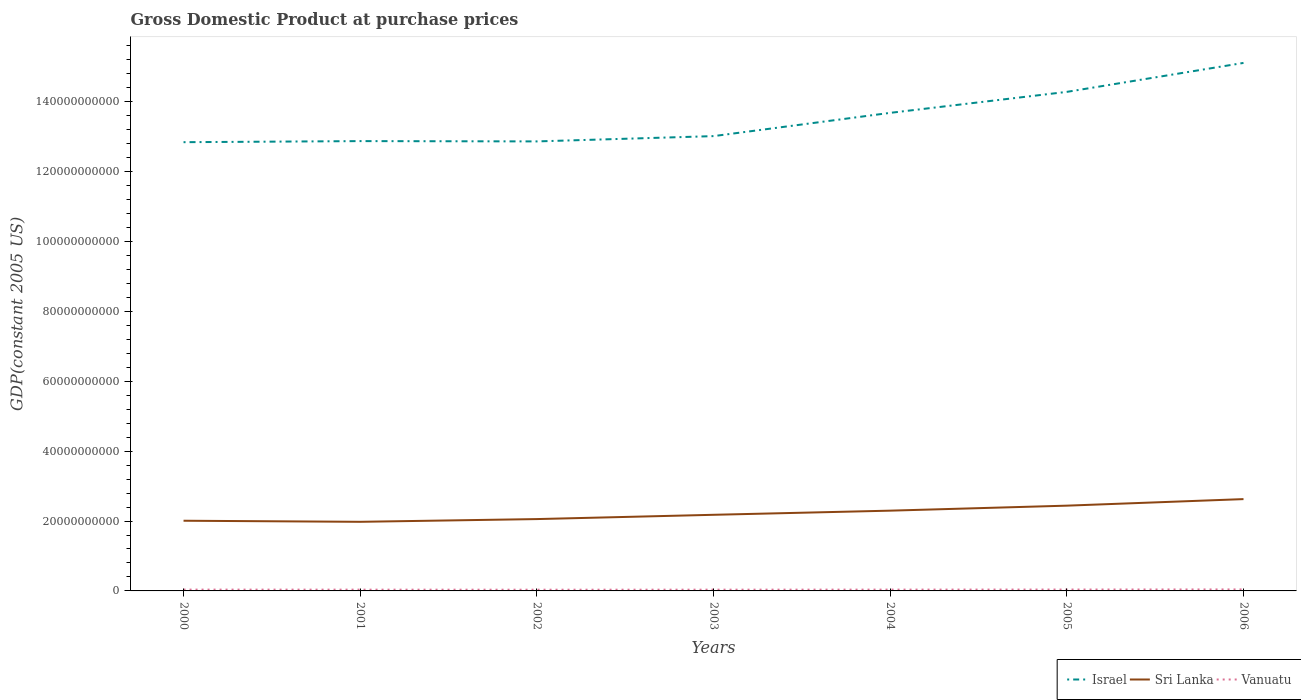Across all years, what is the maximum GDP at purchase prices in Sri Lanka?
Offer a very short reply. 1.98e+1. What is the total GDP at purchase prices in Sri Lanka in the graph?
Your response must be concise. -2.01e+09. What is the difference between the highest and the second highest GDP at purchase prices in Vanuatu?
Your response must be concise. 8.25e+07. Is the GDP at purchase prices in Israel strictly greater than the GDP at purchase prices in Sri Lanka over the years?
Offer a terse response. No. How many legend labels are there?
Give a very brief answer. 3. What is the title of the graph?
Make the answer very short. Gross Domestic Product at purchase prices. Does "Slovenia" appear as one of the legend labels in the graph?
Provide a short and direct response. No. What is the label or title of the X-axis?
Your answer should be compact. Years. What is the label or title of the Y-axis?
Offer a terse response. GDP(constant 2005 US). What is the GDP(constant 2005 US) in Israel in 2000?
Ensure brevity in your answer.  1.28e+11. What is the GDP(constant 2005 US) of Sri Lanka in 2000?
Offer a terse response. 2.01e+1. What is the GDP(constant 2005 US) of Vanuatu in 2000?
Your answer should be very brief. 3.78e+08. What is the GDP(constant 2005 US) in Israel in 2001?
Offer a very short reply. 1.29e+11. What is the GDP(constant 2005 US) of Sri Lanka in 2001?
Make the answer very short. 1.98e+1. What is the GDP(constant 2005 US) of Vanuatu in 2001?
Your answer should be compact. 3.64e+08. What is the GDP(constant 2005 US) of Israel in 2002?
Your response must be concise. 1.29e+11. What is the GDP(constant 2005 US) of Sri Lanka in 2002?
Give a very brief answer. 2.06e+1. What is the GDP(constant 2005 US) in Vanuatu in 2002?
Offer a terse response. 3.46e+08. What is the GDP(constant 2005 US) of Israel in 2003?
Offer a very short reply. 1.30e+11. What is the GDP(constant 2005 US) of Sri Lanka in 2003?
Provide a succinct answer. 2.18e+1. What is the GDP(constant 2005 US) in Vanuatu in 2003?
Provide a succinct answer. 3.61e+08. What is the GDP(constant 2005 US) of Israel in 2004?
Your answer should be compact. 1.37e+11. What is the GDP(constant 2005 US) in Sri Lanka in 2004?
Your answer should be very brief. 2.30e+1. What is the GDP(constant 2005 US) of Vanuatu in 2004?
Offer a very short reply. 3.75e+08. What is the GDP(constant 2005 US) of Israel in 2005?
Offer a terse response. 1.43e+11. What is the GDP(constant 2005 US) of Sri Lanka in 2005?
Your response must be concise. 2.44e+1. What is the GDP(constant 2005 US) of Vanuatu in 2005?
Provide a short and direct response. 3.95e+08. What is the GDP(constant 2005 US) of Israel in 2006?
Offer a terse response. 1.51e+11. What is the GDP(constant 2005 US) in Sri Lanka in 2006?
Provide a succinct answer. 2.63e+1. What is the GDP(constant 2005 US) of Vanuatu in 2006?
Offer a terse response. 4.28e+08. Across all years, what is the maximum GDP(constant 2005 US) of Israel?
Offer a very short reply. 1.51e+11. Across all years, what is the maximum GDP(constant 2005 US) in Sri Lanka?
Your response must be concise. 2.63e+1. Across all years, what is the maximum GDP(constant 2005 US) in Vanuatu?
Offer a terse response. 4.28e+08. Across all years, what is the minimum GDP(constant 2005 US) in Israel?
Make the answer very short. 1.28e+11. Across all years, what is the minimum GDP(constant 2005 US) of Sri Lanka?
Give a very brief answer. 1.98e+1. Across all years, what is the minimum GDP(constant 2005 US) in Vanuatu?
Provide a succinct answer. 3.46e+08. What is the total GDP(constant 2005 US) in Israel in the graph?
Ensure brevity in your answer.  9.47e+11. What is the total GDP(constant 2005 US) in Sri Lanka in the graph?
Your response must be concise. 1.56e+11. What is the total GDP(constant 2005 US) of Vanuatu in the graph?
Your answer should be compact. 2.65e+09. What is the difference between the GDP(constant 2005 US) of Israel in 2000 and that in 2001?
Make the answer very short. -3.10e+08. What is the difference between the GDP(constant 2005 US) in Sri Lanka in 2000 and that in 2001?
Your response must be concise. 3.10e+08. What is the difference between the GDP(constant 2005 US) of Vanuatu in 2000 and that in 2001?
Offer a very short reply. 1.32e+07. What is the difference between the GDP(constant 2005 US) of Israel in 2000 and that in 2002?
Offer a very short reply. -2.22e+08. What is the difference between the GDP(constant 2005 US) in Sri Lanka in 2000 and that in 2002?
Offer a terse response. -4.74e+08. What is the difference between the GDP(constant 2005 US) in Vanuatu in 2000 and that in 2002?
Offer a very short reply. 3.18e+07. What is the difference between the GDP(constant 2005 US) of Israel in 2000 and that in 2003?
Offer a very short reply. -1.74e+09. What is the difference between the GDP(constant 2005 US) in Sri Lanka in 2000 and that in 2003?
Ensure brevity in your answer.  -1.70e+09. What is the difference between the GDP(constant 2005 US) in Vanuatu in 2000 and that in 2003?
Keep it short and to the point. 1.70e+07. What is the difference between the GDP(constant 2005 US) of Israel in 2000 and that in 2004?
Give a very brief answer. -8.39e+09. What is the difference between the GDP(constant 2005 US) of Sri Lanka in 2000 and that in 2004?
Your response must be concise. -2.88e+09. What is the difference between the GDP(constant 2005 US) of Vanuatu in 2000 and that in 2004?
Offer a terse response. 2.58e+06. What is the difference between the GDP(constant 2005 US) in Israel in 2000 and that in 2005?
Your answer should be very brief. -1.44e+1. What is the difference between the GDP(constant 2005 US) of Sri Lanka in 2000 and that in 2005?
Offer a terse response. -4.32e+09. What is the difference between the GDP(constant 2005 US) in Vanuatu in 2000 and that in 2005?
Your answer should be compact. -1.73e+07. What is the difference between the GDP(constant 2005 US) of Israel in 2000 and that in 2006?
Provide a succinct answer. -2.27e+1. What is the difference between the GDP(constant 2005 US) in Sri Lanka in 2000 and that in 2006?
Keep it short and to the point. -6.19e+09. What is the difference between the GDP(constant 2005 US) in Vanuatu in 2000 and that in 2006?
Provide a succinct answer. -5.07e+07. What is the difference between the GDP(constant 2005 US) in Israel in 2001 and that in 2002?
Your response must be concise. 8.79e+07. What is the difference between the GDP(constant 2005 US) of Sri Lanka in 2001 and that in 2002?
Provide a succinct answer. -7.84e+08. What is the difference between the GDP(constant 2005 US) in Vanuatu in 2001 and that in 2002?
Make the answer very short. 1.86e+07. What is the difference between the GDP(constant 2005 US) in Israel in 2001 and that in 2003?
Give a very brief answer. -1.43e+09. What is the difference between the GDP(constant 2005 US) of Sri Lanka in 2001 and that in 2003?
Your response must be concise. -2.01e+09. What is the difference between the GDP(constant 2005 US) of Vanuatu in 2001 and that in 2003?
Keep it short and to the point. 3.78e+06. What is the difference between the GDP(constant 2005 US) of Israel in 2001 and that in 2004?
Give a very brief answer. -8.08e+09. What is the difference between the GDP(constant 2005 US) of Sri Lanka in 2001 and that in 2004?
Keep it short and to the point. -3.19e+09. What is the difference between the GDP(constant 2005 US) in Vanuatu in 2001 and that in 2004?
Provide a succinct answer. -1.06e+07. What is the difference between the GDP(constant 2005 US) of Israel in 2001 and that in 2005?
Your answer should be very brief. -1.41e+1. What is the difference between the GDP(constant 2005 US) of Sri Lanka in 2001 and that in 2005?
Your response must be concise. -4.63e+09. What is the difference between the GDP(constant 2005 US) of Vanuatu in 2001 and that in 2005?
Your answer should be compact. -3.05e+07. What is the difference between the GDP(constant 2005 US) in Israel in 2001 and that in 2006?
Offer a very short reply. -2.24e+1. What is the difference between the GDP(constant 2005 US) of Sri Lanka in 2001 and that in 2006?
Offer a very short reply. -6.50e+09. What is the difference between the GDP(constant 2005 US) of Vanuatu in 2001 and that in 2006?
Provide a succinct answer. -6.39e+07. What is the difference between the GDP(constant 2005 US) in Israel in 2002 and that in 2003?
Offer a terse response. -1.51e+09. What is the difference between the GDP(constant 2005 US) of Sri Lanka in 2002 and that in 2003?
Keep it short and to the point. -1.22e+09. What is the difference between the GDP(constant 2005 US) in Vanuatu in 2002 and that in 2003?
Make the answer very short. -1.48e+07. What is the difference between the GDP(constant 2005 US) in Israel in 2002 and that in 2004?
Offer a terse response. -8.17e+09. What is the difference between the GDP(constant 2005 US) in Sri Lanka in 2002 and that in 2004?
Your answer should be compact. -2.41e+09. What is the difference between the GDP(constant 2005 US) of Vanuatu in 2002 and that in 2004?
Ensure brevity in your answer.  -2.92e+07. What is the difference between the GDP(constant 2005 US) in Israel in 2002 and that in 2005?
Ensure brevity in your answer.  -1.42e+1. What is the difference between the GDP(constant 2005 US) in Sri Lanka in 2002 and that in 2005?
Offer a very short reply. -3.84e+09. What is the difference between the GDP(constant 2005 US) in Vanuatu in 2002 and that in 2005?
Give a very brief answer. -4.91e+07. What is the difference between the GDP(constant 2005 US) of Israel in 2002 and that in 2006?
Provide a succinct answer. -2.25e+1. What is the difference between the GDP(constant 2005 US) of Sri Lanka in 2002 and that in 2006?
Your answer should be very brief. -5.71e+09. What is the difference between the GDP(constant 2005 US) in Vanuatu in 2002 and that in 2006?
Make the answer very short. -8.25e+07. What is the difference between the GDP(constant 2005 US) in Israel in 2003 and that in 2004?
Your response must be concise. -6.66e+09. What is the difference between the GDP(constant 2005 US) of Sri Lanka in 2003 and that in 2004?
Offer a terse response. -1.19e+09. What is the difference between the GDP(constant 2005 US) of Vanuatu in 2003 and that in 2004?
Keep it short and to the point. -1.44e+07. What is the difference between the GDP(constant 2005 US) of Israel in 2003 and that in 2005?
Give a very brief answer. -1.27e+1. What is the difference between the GDP(constant 2005 US) of Sri Lanka in 2003 and that in 2005?
Offer a terse response. -2.62e+09. What is the difference between the GDP(constant 2005 US) in Vanuatu in 2003 and that in 2005?
Your answer should be very brief. -3.43e+07. What is the difference between the GDP(constant 2005 US) of Israel in 2003 and that in 2006?
Give a very brief answer. -2.10e+1. What is the difference between the GDP(constant 2005 US) in Sri Lanka in 2003 and that in 2006?
Provide a short and direct response. -4.49e+09. What is the difference between the GDP(constant 2005 US) of Vanuatu in 2003 and that in 2006?
Your answer should be compact. -6.77e+07. What is the difference between the GDP(constant 2005 US) in Israel in 2004 and that in 2005?
Offer a terse response. -6.01e+09. What is the difference between the GDP(constant 2005 US) in Sri Lanka in 2004 and that in 2005?
Provide a short and direct response. -1.43e+09. What is the difference between the GDP(constant 2005 US) in Vanuatu in 2004 and that in 2005?
Make the answer very short. -1.99e+07. What is the difference between the GDP(constant 2005 US) of Israel in 2004 and that in 2006?
Provide a succinct answer. -1.43e+1. What is the difference between the GDP(constant 2005 US) in Sri Lanka in 2004 and that in 2006?
Provide a short and direct response. -3.31e+09. What is the difference between the GDP(constant 2005 US) in Vanuatu in 2004 and that in 2006?
Provide a short and direct response. -5.33e+07. What is the difference between the GDP(constant 2005 US) in Israel in 2005 and that in 2006?
Your answer should be very brief. -8.29e+09. What is the difference between the GDP(constant 2005 US) in Sri Lanka in 2005 and that in 2006?
Your answer should be very brief. -1.87e+09. What is the difference between the GDP(constant 2005 US) of Vanuatu in 2005 and that in 2006?
Your answer should be very brief. -3.34e+07. What is the difference between the GDP(constant 2005 US) of Israel in 2000 and the GDP(constant 2005 US) of Sri Lanka in 2001?
Your answer should be very brief. 1.09e+11. What is the difference between the GDP(constant 2005 US) of Israel in 2000 and the GDP(constant 2005 US) of Vanuatu in 2001?
Your answer should be very brief. 1.28e+11. What is the difference between the GDP(constant 2005 US) in Sri Lanka in 2000 and the GDP(constant 2005 US) in Vanuatu in 2001?
Your answer should be very brief. 1.97e+1. What is the difference between the GDP(constant 2005 US) in Israel in 2000 and the GDP(constant 2005 US) in Sri Lanka in 2002?
Your answer should be compact. 1.08e+11. What is the difference between the GDP(constant 2005 US) in Israel in 2000 and the GDP(constant 2005 US) in Vanuatu in 2002?
Provide a succinct answer. 1.28e+11. What is the difference between the GDP(constant 2005 US) of Sri Lanka in 2000 and the GDP(constant 2005 US) of Vanuatu in 2002?
Provide a short and direct response. 1.97e+1. What is the difference between the GDP(constant 2005 US) of Israel in 2000 and the GDP(constant 2005 US) of Sri Lanka in 2003?
Give a very brief answer. 1.07e+11. What is the difference between the GDP(constant 2005 US) in Israel in 2000 and the GDP(constant 2005 US) in Vanuatu in 2003?
Your answer should be compact. 1.28e+11. What is the difference between the GDP(constant 2005 US) of Sri Lanka in 2000 and the GDP(constant 2005 US) of Vanuatu in 2003?
Provide a short and direct response. 1.97e+1. What is the difference between the GDP(constant 2005 US) in Israel in 2000 and the GDP(constant 2005 US) in Sri Lanka in 2004?
Ensure brevity in your answer.  1.05e+11. What is the difference between the GDP(constant 2005 US) in Israel in 2000 and the GDP(constant 2005 US) in Vanuatu in 2004?
Your answer should be very brief. 1.28e+11. What is the difference between the GDP(constant 2005 US) in Sri Lanka in 2000 and the GDP(constant 2005 US) in Vanuatu in 2004?
Your answer should be very brief. 1.97e+1. What is the difference between the GDP(constant 2005 US) in Israel in 2000 and the GDP(constant 2005 US) in Sri Lanka in 2005?
Keep it short and to the point. 1.04e+11. What is the difference between the GDP(constant 2005 US) in Israel in 2000 and the GDP(constant 2005 US) in Vanuatu in 2005?
Your answer should be compact. 1.28e+11. What is the difference between the GDP(constant 2005 US) in Sri Lanka in 2000 and the GDP(constant 2005 US) in Vanuatu in 2005?
Make the answer very short. 1.97e+1. What is the difference between the GDP(constant 2005 US) in Israel in 2000 and the GDP(constant 2005 US) in Sri Lanka in 2006?
Your answer should be compact. 1.02e+11. What is the difference between the GDP(constant 2005 US) in Israel in 2000 and the GDP(constant 2005 US) in Vanuatu in 2006?
Provide a short and direct response. 1.28e+11. What is the difference between the GDP(constant 2005 US) in Sri Lanka in 2000 and the GDP(constant 2005 US) in Vanuatu in 2006?
Give a very brief answer. 1.97e+1. What is the difference between the GDP(constant 2005 US) in Israel in 2001 and the GDP(constant 2005 US) in Sri Lanka in 2002?
Ensure brevity in your answer.  1.08e+11. What is the difference between the GDP(constant 2005 US) of Israel in 2001 and the GDP(constant 2005 US) of Vanuatu in 2002?
Keep it short and to the point. 1.28e+11. What is the difference between the GDP(constant 2005 US) in Sri Lanka in 2001 and the GDP(constant 2005 US) in Vanuatu in 2002?
Offer a very short reply. 1.94e+1. What is the difference between the GDP(constant 2005 US) of Israel in 2001 and the GDP(constant 2005 US) of Sri Lanka in 2003?
Provide a succinct answer. 1.07e+11. What is the difference between the GDP(constant 2005 US) in Israel in 2001 and the GDP(constant 2005 US) in Vanuatu in 2003?
Your answer should be compact. 1.28e+11. What is the difference between the GDP(constant 2005 US) in Sri Lanka in 2001 and the GDP(constant 2005 US) in Vanuatu in 2003?
Offer a terse response. 1.94e+1. What is the difference between the GDP(constant 2005 US) of Israel in 2001 and the GDP(constant 2005 US) of Sri Lanka in 2004?
Provide a short and direct response. 1.06e+11. What is the difference between the GDP(constant 2005 US) of Israel in 2001 and the GDP(constant 2005 US) of Vanuatu in 2004?
Keep it short and to the point. 1.28e+11. What is the difference between the GDP(constant 2005 US) in Sri Lanka in 2001 and the GDP(constant 2005 US) in Vanuatu in 2004?
Your answer should be very brief. 1.94e+1. What is the difference between the GDP(constant 2005 US) of Israel in 2001 and the GDP(constant 2005 US) of Sri Lanka in 2005?
Your answer should be very brief. 1.04e+11. What is the difference between the GDP(constant 2005 US) of Israel in 2001 and the GDP(constant 2005 US) of Vanuatu in 2005?
Ensure brevity in your answer.  1.28e+11. What is the difference between the GDP(constant 2005 US) in Sri Lanka in 2001 and the GDP(constant 2005 US) in Vanuatu in 2005?
Give a very brief answer. 1.94e+1. What is the difference between the GDP(constant 2005 US) of Israel in 2001 and the GDP(constant 2005 US) of Sri Lanka in 2006?
Make the answer very short. 1.02e+11. What is the difference between the GDP(constant 2005 US) in Israel in 2001 and the GDP(constant 2005 US) in Vanuatu in 2006?
Provide a succinct answer. 1.28e+11. What is the difference between the GDP(constant 2005 US) in Sri Lanka in 2001 and the GDP(constant 2005 US) in Vanuatu in 2006?
Provide a short and direct response. 1.94e+1. What is the difference between the GDP(constant 2005 US) in Israel in 2002 and the GDP(constant 2005 US) in Sri Lanka in 2003?
Offer a terse response. 1.07e+11. What is the difference between the GDP(constant 2005 US) in Israel in 2002 and the GDP(constant 2005 US) in Vanuatu in 2003?
Provide a succinct answer. 1.28e+11. What is the difference between the GDP(constant 2005 US) of Sri Lanka in 2002 and the GDP(constant 2005 US) of Vanuatu in 2003?
Offer a terse response. 2.02e+1. What is the difference between the GDP(constant 2005 US) of Israel in 2002 and the GDP(constant 2005 US) of Sri Lanka in 2004?
Provide a short and direct response. 1.06e+11. What is the difference between the GDP(constant 2005 US) in Israel in 2002 and the GDP(constant 2005 US) in Vanuatu in 2004?
Provide a succinct answer. 1.28e+11. What is the difference between the GDP(constant 2005 US) of Sri Lanka in 2002 and the GDP(constant 2005 US) of Vanuatu in 2004?
Your answer should be very brief. 2.02e+1. What is the difference between the GDP(constant 2005 US) in Israel in 2002 and the GDP(constant 2005 US) in Sri Lanka in 2005?
Ensure brevity in your answer.  1.04e+11. What is the difference between the GDP(constant 2005 US) in Israel in 2002 and the GDP(constant 2005 US) in Vanuatu in 2005?
Provide a short and direct response. 1.28e+11. What is the difference between the GDP(constant 2005 US) of Sri Lanka in 2002 and the GDP(constant 2005 US) of Vanuatu in 2005?
Your answer should be very brief. 2.02e+1. What is the difference between the GDP(constant 2005 US) in Israel in 2002 and the GDP(constant 2005 US) in Sri Lanka in 2006?
Make the answer very short. 1.02e+11. What is the difference between the GDP(constant 2005 US) in Israel in 2002 and the GDP(constant 2005 US) in Vanuatu in 2006?
Provide a short and direct response. 1.28e+11. What is the difference between the GDP(constant 2005 US) in Sri Lanka in 2002 and the GDP(constant 2005 US) in Vanuatu in 2006?
Provide a succinct answer. 2.01e+1. What is the difference between the GDP(constant 2005 US) in Israel in 2003 and the GDP(constant 2005 US) in Sri Lanka in 2004?
Offer a terse response. 1.07e+11. What is the difference between the GDP(constant 2005 US) in Israel in 2003 and the GDP(constant 2005 US) in Vanuatu in 2004?
Provide a short and direct response. 1.30e+11. What is the difference between the GDP(constant 2005 US) in Sri Lanka in 2003 and the GDP(constant 2005 US) in Vanuatu in 2004?
Your answer should be compact. 2.14e+1. What is the difference between the GDP(constant 2005 US) of Israel in 2003 and the GDP(constant 2005 US) of Sri Lanka in 2005?
Offer a very short reply. 1.06e+11. What is the difference between the GDP(constant 2005 US) in Israel in 2003 and the GDP(constant 2005 US) in Vanuatu in 2005?
Give a very brief answer. 1.30e+11. What is the difference between the GDP(constant 2005 US) of Sri Lanka in 2003 and the GDP(constant 2005 US) of Vanuatu in 2005?
Provide a short and direct response. 2.14e+1. What is the difference between the GDP(constant 2005 US) of Israel in 2003 and the GDP(constant 2005 US) of Sri Lanka in 2006?
Your response must be concise. 1.04e+11. What is the difference between the GDP(constant 2005 US) of Israel in 2003 and the GDP(constant 2005 US) of Vanuatu in 2006?
Provide a succinct answer. 1.30e+11. What is the difference between the GDP(constant 2005 US) in Sri Lanka in 2003 and the GDP(constant 2005 US) in Vanuatu in 2006?
Provide a succinct answer. 2.14e+1. What is the difference between the GDP(constant 2005 US) in Israel in 2004 and the GDP(constant 2005 US) in Sri Lanka in 2005?
Your answer should be compact. 1.12e+11. What is the difference between the GDP(constant 2005 US) of Israel in 2004 and the GDP(constant 2005 US) of Vanuatu in 2005?
Your answer should be compact. 1.36e+11. What is the difference between the GDP(constant 2005 US) in Sri Lanka in 2004 and the GDP(constant 2005 US) in Vanuatu in 2005?
Make the answer very short. 2.26e+1. What is the difference between the GDP(constant 2005 US) of Israel in 2004 and the GDP(constant 2005 US) of Sri Lanka in 2006?
Your answer should be compact. 1.11e+11. What is the difference between the GDP(constant 2005 US) in Israel in 2004 and the GDP(constant 2005 US) in Vanuatu in 2006?
Give a very brief answer. 1.36e+11. What is the difference between the GDP(constant 2005 US) in Sri Lanka in 2004 and the GDP(constant 2005 US) in Vanuatu in 2006?
Ensure brevity in your answer.  2.25e+1. What is the difference between the GDP(constant 2005 US) in Israel in 2005 and the GDP(constant 2005 US) in Sri Lanka in 2006?
Provide a short and direct response. 1.17e+11. What is the difference between the GDP(constant 2005 US) of Israel in 2005 and the GDP(constant 2005 US) of Vanuatu in 2006?
Give a very brief answer. 1.42e+11. What is the difference between the GDP(constant 2005 US) in Sri Lanka in 2005 and the GDP(constant 2005 US) in Vanuatu in 2006?
Ensure brevity in your answer.  2.40e+1. What is the average GDP(constant 2005 US) of Israel per year?
Keep it short and to the point. 1.35e+11. What is the average GDP(constant 2005 US) of Sri Lanka per year?
Give a very brief answer. 2.23e+1. What is the average GDP(constant 2005 US) in Vanuatu per year?
Keep it short and to the point. 3.78e+08. In the year 2000, what is the difference between the GDP(constant 2005 US) in Israel and GDP(constant 2005 US) in Sri Lanka?
Make the answer very short. 1.08e+11. In the year 2000, what is the difference between the GDP(constant 2005 US) in Israel and GDP(constant 2005 US) in Vanuatu?
Offer a very short reply. 1.28e+11. In the year 2000, what is the difference between the GDP(constant 2005 US) in Sri Lanka and GDP(constant 2005 US) in Vanuatu?
Provide a short and direct response. 1.97e+1. In the year 2001, what is the difference between the GDP(constant 2005 US) in Israel and GDP(constant 2005 US) in Sri Lanka?
Your answer should be very brief. 1.09e+11. In the year 2001, what is the difference between the GDP(constant 2005 US) of Israel and GDP(constant 2005 US) of Vanuatu?
Ensure brevity in your answer.  1.28e+11. In the year 2001, what is the difference between the GDP(constant 2005 US) in Sri Lanka and GDP(constant 2005 US) in Vanuatu?
Offer a very short reply. 1.94e+1. In the year 2002, what is the difference between the GDP(constant 2005 US) of Israel and GDP(constant 2005 US) of Sri Lanka?
Your response must be concise. 1.08e+11. In the year 2002, what is the difference between the GDP(constant 2005 US) of Israel and GDP(constant 2005 US) of Vanuatu?
Provide a succinct answer. 1.28e+11. In the year 2002, what is the difference between the GDP(constant 2005 US) in Sri Lanka and GDP(constant 2005 US) in Vanuatu?
Ensure brevity in your answer.  2.02e+1. In the year 2003, what is the difference between the GDP(constant 2005 US) of Israel and GDP(constant 2005 US) of Sri Lanka?
Ensure brevity in your answer.  1.08e+11. In the year 2003, what is the difference between the GDP(constant 2005 US) in Israel and GDP(constant 2005 US) in Vanuatu?
Make the answer very short. 1.30e+11. In the year 2003, what is the difference between the GDP(constant 2005 US) in Sri Lanka and GDP(constant 2005 US) in Vanuatu?
Ensure brevity in your answer.  2.14e+1. In the year 2004, what is the difference between the GDP(constant 2005 US) of Israel and GDP(constant 2005 US) of Sri Lanka?
Provide a succinct answer. 1.14e+11. In the year 2004, what is the difference between the GDP(constant 2005 US) of Israel and GDP(constant 2005 US) of Vanuatu?
Give a very brief answer. 1.36e+11. In the year 2004, what is the difference between the GDP(constant 2005 US) in Sri Lanka and GDP(constant 2005 US) in Vanuatu?
Make the answer very short. 2.26e+1. In the year 2005, what is the difference between the GDP(constant 2005 US) of Israel and GDP(constant 2005 US) of Sri Lanka?
Offer a terse response. 1.18e+11. In the year 2005, what is the difference between the GDP(constant 2005 US) of Israel and GDP(constant 2005 US) of Vanuatu?
Ensure brevity in your answer.  1.42e+11. In the year 2005, what is the difference between the GDP(constant 2005 US) of Sri Lanka and GDP(constant 2005 US) of Vanuatu?
Offer a very short reply. 2.40e+1. In the year 2006, what is the difference between the GDP(constant 2005 US) of Israel and GDP(constant 2005 US) of Sri Lanka?
Provide a short and direct response. 1.25e+11. In the year 2006, what is the difference between the GDP(constant 2005 US) in Israel and GDP(constant 2005 US) in Vanuatu?
Ensure brevity in your answer.  1.51e+11. In the year 2006, what is the difference between the GDP(constant 2005 US) in Sri Lanka and GDP(constant 2005 US) in Vanuatu?
Give a very brief answer. 2.58e+1. What is the ratio of the GDP(constant 2005 US) in Sri Lanka in 2000 to that in 2001?
Your response must be concise. 1.02. What is the ratio of the GDP(constant 2005 US) in Vanuatu in 2000 to that in 2001?
Provide a short and direct response. 1.04. What is the ratio of the GDP(constant 2005 US) in Israel in 2000 to that in 2002?
Make the answer very short. 1. What is the ratio of the GDP(constant 2005 US) in Sri Lanka in 2000 to that in 2002?
Make the answer very short. 0.98. What is the ratio of the GDP(constant 2005 US) of Vanuatu in 2000 to that in 2002?
Give a very brief answer. 1.09. What is the ratio of the GDP(constant 2005 US) of Israel in 2000 to that in 2003?
Your answer should be very brief. 0.99. What is the ratio of the GDP(constant 2005 US) of Sri Lanka in 2000 to that in 2003?
Your answer should be compact. 0.92. What is the ratio of the GDP(constant 2005 US) of Vanuatu in 2000 to that in 2003?
Make the answer very short. 1.05. What is the ratio of the GDP(constant 2005 US) of Israel in 2000 to that in 2004?
Offer a very short reply. 0.94. What is the ratio of the GDP(constant 2005 US) of Sri Lanka in 2000 to that in 2004?
Offer a very short reply. 0.87. What is the ratio of the GDP(constant 2005 US) in Vanuatu in 2000 to that in 2004?
Make the answer very short. 1.01. What is the ratio of the GDP(constant 2005 US) in Israel in 2000 to that in 2005?
Make the answer very short. 0.9. What is the ratio of the GDP(constant 2005 US) in Sri Lanka in 2000 to that in 2005?
Provide a succinct answer. 0.82. What is the ratio of the GDP(constant 2005 US) of Vanuatu in 2000 to that in 2005?
Provide a short and direct response. 0.96. What is the ratio of the GDP(constant 2005 US) in Israel in 2000 to that in 2006?
Offer a terse response. 0.85. What is the ratio of the GDP(constant 2005 US) in Sri Lanka in 2000 to that in 2006?
Your response must be concise. 0.76. What is the ratio of the GDP(constant 2005 US) of Vanuatu in 2000 to that in 2006?
Your answer should be compact. 0.88. What is the ratio of the GDP(constant 2005 US) in Israel in 2001 to that in 2002?
Offer a terse response. 1. What is the ratio of the GDP(constant 2005 US) of Sri Lanka in 2001 to that in 2002?
Your answer should be compact. 0.96. What is the ratio of the GDP(constant 2005 US) of Vanuatu in 2001 to that in 2002?
Make the answer very short. 1.05. What is the ratio of the GDP(constant 2005 US) in Sri Lanka in 2001 to that in 2003?
Offer a very short reply. 0.91. What is the ratio of the GDP(constant 2005 US) of Vanuatu in 2001 to that in 2003?
Provide a short and direct response. 1.01. What is the ratio of the GDP(constant 2005 US) of Israel in 2001 to that in 2004?
Offer a very short reply. 0.94. What is the ratio of the GDP(constant 2005 US) in Sri Lanka in 2001 to that in 2004?
Your response must be concise. 0.86. What is the ratio of the GDP(constant 2005 US) in Vanuatu in 2001 to that in 2004?
Keep it short and to the point. 0.97. What is the ratio of the GDP(constant 2005 US) of Israel in 2001 to that in 2005?
Provide a succinct answer. 0.9. What is the ratio of the GDP(constant 2005 US) in Sri Lanka in 2001 to that in 2005?
Offer a terse response. 0.81. What is the ratio of the GDP(constant 2005 US) in Vanuatu in 2001 to that in 2005?
Provide a succinct answer. 0.92. What is the ratio of the GDP(constant 2005 US) of Israel in 2001 to that in 2006?
Make the answer very short. 0.85. What is the ratio of the GDP(constant 2005 US) of Sri Lanka in 2001 to that in 2006?
Keep it short and to the point. 0.75. What is the ratio of the GDP(constant 2005 US) in Vanuatu in 2001 to that in 2006?
Your answer should be very brief. 0.85. What is the ratio of the GDP(constant 2005 US) in Israel in 2002 to that in 2003?
Offer a very short reply. 0.99. What is the ratio of the GDP(constant 2005 US) of Sri Lanka in 2002 to that in 2003?
Your answer should be very brief. 0.94. What is the ratio of the GDP(constant 2005 US) in Vanuatu in 2002 to that in 2003?
Provide a succinct answer. 0.96. What is the ratio of the GDP(constant 2005 US) in Israel in 2002 to that in 2004?
Offer a terse response. 0.94. What is the ratio of the GDP(constant 2005 US) in Sri Lanka in 2002 to that in 2004?
Your response must be concise. 0.9. What is the ratio of the GDP(constant 2005 US) in Vanuatu in 2002 to that in 2004?
Ensure brevity in your answer.  0.92. What is the ratio of the GDP(constant 2005 US) of Israel in 2002 to that in 2005?
Your response must be concise. 0.9. What is the ratio of the GDP(constant 2005 US) in Sri Lanka in 2002 to that in 2005?
Your response must be concise. 0.84. What is the ratio of the GDP(constant 2005 US) in Vanuatu in 2002 to that in 2005?
Offer a very short reply. 0.88. What is the ratio of the GDP(constant 2005 US) of Israel in 2002 to that in 2006?
Your response must be concise. 0.85. What is the ratio of the GDP(constant 2005 US) of Sri Lanka in 2002 to that in 2006?
Provide a short and direct response. 0.78. What is the ratio of the GDP(constant 2005 US) of Vanuatu in 2002 to that in 2006?
Your answer should be compact. 0.81. What is the ratio of the GDP(constant 2005 US) in Israel in 2003 to that in 2004?
Ensure brevity in your answer.  0.95. What is the ratio of the GDP(constant 2005 US) of Sri Lanka in 2003 to that in 2004?
Offer a terse response. 0.95. What is the ratio of the GDP(constant 2005 US) of Vanuatu in 2003 to that in 2004?
Make the answer very short. 0.96. What is the ratio of the GDP(constant 2005 US) in Israel in 2003 to that in 2005?
Give a very brief answer. 0.91. What is the ratio of the GDP(constant 2005 US) in Sri Lanka in 2003 to that in 2005?
Offer a terse response. 0.89. What is the ratio of the GDP(constant 2005 US) of Vanuatu in 2003 to that in 2005?
Give a very brief answer. 0.91. What is the ratio of the GDP(constant 2005 US) of Israel in 2003 to that in 2006?
Ensure brevity in your answer.  0.86. What is the ratio of the GDP(constant 2005 US) in Sri Lanka in 2003 to that in 2006?
Your answer should be very brief. 0.83. What is the ratio of the GDP(constant 2005 US) of Vanuatu in 2003 to that in 2006?
Provide a short and direct response. 0.84. What is the ratio of the GDP(constant 2005 US) of Israel in 2004 to that in 2005?
Offer a terse response. 0.96. What is the ratio of the GDP(constant 2005 US) of Vanuatu in 2004 to that in 2005?
Offer a terse response. 0.95. What is the ratio of the GDP(constant 2005 US) of Israel in 2004 to that in 2006?
Provide a short and direct response. 0.91. What is the ratio of the GDP(constant 2005 US) in Sri Lanka in 2004 to that in 2006?
Provide a succinct answer. 0.87. What is the ratio of the GDP(constant 2005 US) of Vanuatu in 2004 to that in 2006?
Provide a succinct answer. 0.88. What is the ratio of the GDP(constant 2005 US) of Israel in 2005 to that in 2006?
Give a very brief answer. 0.95. What is the ratio of the GDP(constant 2005 US) in Sri Lanka in 2005 to that in 2006?
Make the answer very short. 0.93. What is the ratio of the GDP(constant 2005 US) of Vanuatu in 2005 to that in 2006?
Ensure brevity in your answer.  0.92. What is the difference between the highest and the second highest GDP(constant 2005 US) of Israel?
Your answer should be compact. 8.29e+09. What is the difference between the highest and the second highest GDP(constant 2005 US) in Sri Lanka?
Provide a short and direct response. 1.87e+09. What is the difference between the highest and the second highest GDP(constant 2005 US) in Vanuatu?
Offer a terse response. 3.34e+07. What is the difference between the highest and the lowest GDP(constant 2005 US) of Israel?
Your response must be concise. 2.27e+1. What is the difference between the highest and the lowest GDP(constant 2005 US) of Sri Lanka?
Your answer should be very brief. 6.50e+09. What is the difference between the highest and the lowest GDP(constant 2005 US) in Vanuatu?
Your answer should be compact. 8.25e+07. 